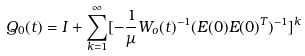Convert formula to latex. <formula><loc_0><loc_0><loc_500><loc_500>Q _ { 0 } ( t ) = I + \sum _ { k = 1 } ^ { \infty } [ - \frac { 1 } { \mu } W _ { o } ( t ) ^ { - 1 } ( E ( 0 ) E ( 0 ) ^ { T } ) ^ { - 1 } ] ^ { k }</formula> 